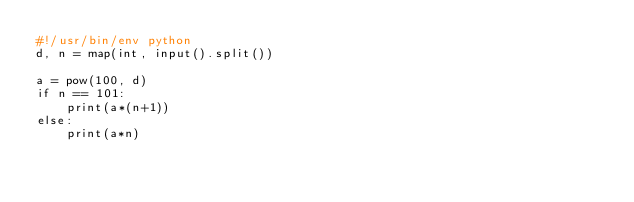Convert code to text. <code><loc_0><loc_0><loc_500><loc_500><_Python_>#!/usr/bin/env python
d, n = map(int, input().split())

a = pow(100, d)
if n == 101:
    print(a*(n+1))
else:
    print(a*n)</code> 